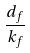<formula> <loc_0><loc_0><loc_500><loc_500>\frac { d _ { f } } { k _ { f } }</formula> 